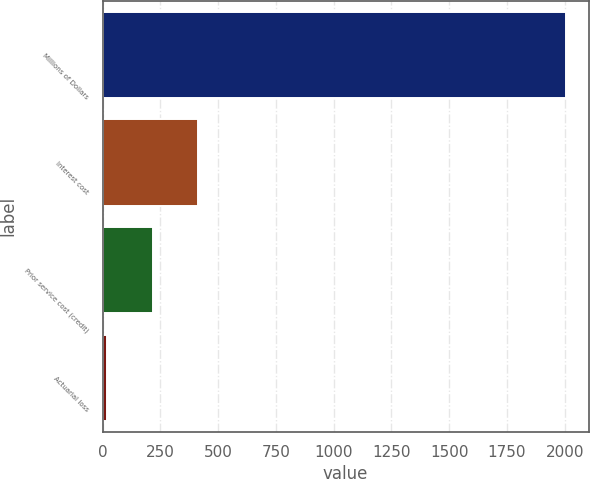<chart> <loc_0><loc_0><loc_500><loc_500><bar_chart><fcel>Millions of Dollars<fcel>Interest cost<fcel>Prior service cost (credit)<fcel>Actuarial loss<nl><fcel>2004<fcel>415.2<fcel>216.6<fcel>18<nl></chart> 